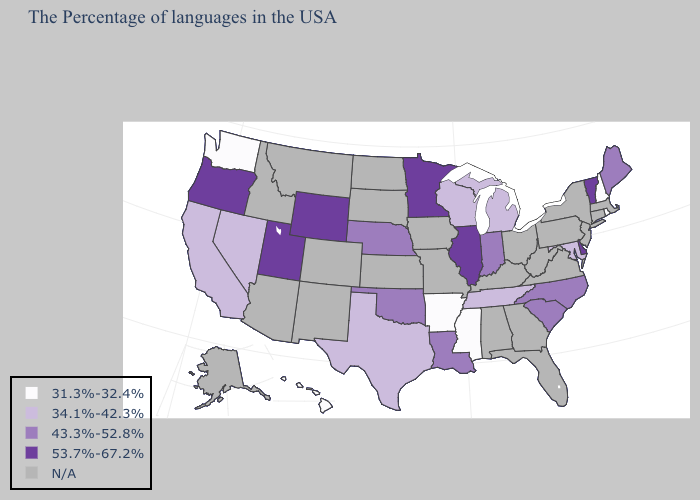Name the states that have a value in the range 31.3%-32.4%?
Be succinct. Rhode Island, New Hampshire, Mississippi, Arkansas, Washington, Hawaii. Among the states that border Michigan , does Indiana have the highest value?
Write a very short answer. Yes. Which states have the lowest value in the USA?
Concise answer only. Rhode Island, New Hampshire, Mississippi, Arkansas, Washington, Hawaii. Name the states that have a value in the range N/A?
Concise answer only. Massachusetts, Connecticut, New York, New Jersey, Pennsylvania, Virginia, West Virginia, Ohio, Florida, Georgia, Kentucky, Alabama, Missouri, Iowa, Kansas, South Dakota, North Dakota, Colorado, New Mexico, Montana, Arizona, Idaho, Alaska. What is the value of Tennessee?
Quick response, please. 34.1%-42.3%. Name the states that have a value in the range 43.3%-52.8%?
Give a very brief answer. Maine, North Carolina, South Carolina, Indiana, Louisiana, Nebraska, Oklahoma. What is the value of South Dakota?
Concise answer only. N/A. Name the states that have a value in the range 34.1%-42.3%?
Concise answer only. Maryland, Michigan, Tennessee, Wisconsin, Texas, Nevada, California. What is the value of Connecticut?
Concise answer only. N/A. Name the states that have a value in the range 34.1%-42.3%?
Be succinct. Maryland, Michigan, Tennessee, Wisconsin, Texas, Nevada, California. Among the states that border Kentucky , which have the lowest value?
Keep it brief. Tennessee. Name the states that have a value in the range 31.3%-32.4%?
Quick response, please. Rhode Island, New Hampshire, Mississippi, Arkansas, Washington, Hawaii. Does Washington have the lowest value in the USA?
Answer briefly. Yes. Name the states that have a value in the range 31.3%-32.4%?
Be succinct. Rhode Island, New Hampshire, Mississippi, Arkansas, Washington, Hawaii. Name the states that have a value in the range 31.3%-32.4%?
Write a very short answer. Rhode Island, New Hampshire, Mississippi, Arkansas, Washington, Hawaii. 